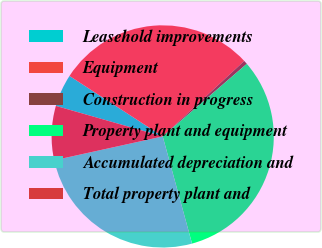<chart> <loc_0><loc_0><loc_500><loc_500><pie_chart><fcel>Leasehold improvements<fcel>Equipment<fcel>Construction in progress<fcel>Property plant and equipment<fcel>Accumulated depreciation and<fcel>Total property plant and<nl><fcel>4.73%<fcel>28.95%<fcel>0.55%<fcel>32.08%<fcel>25.81%<fcel>7.87%<nl></chart> 